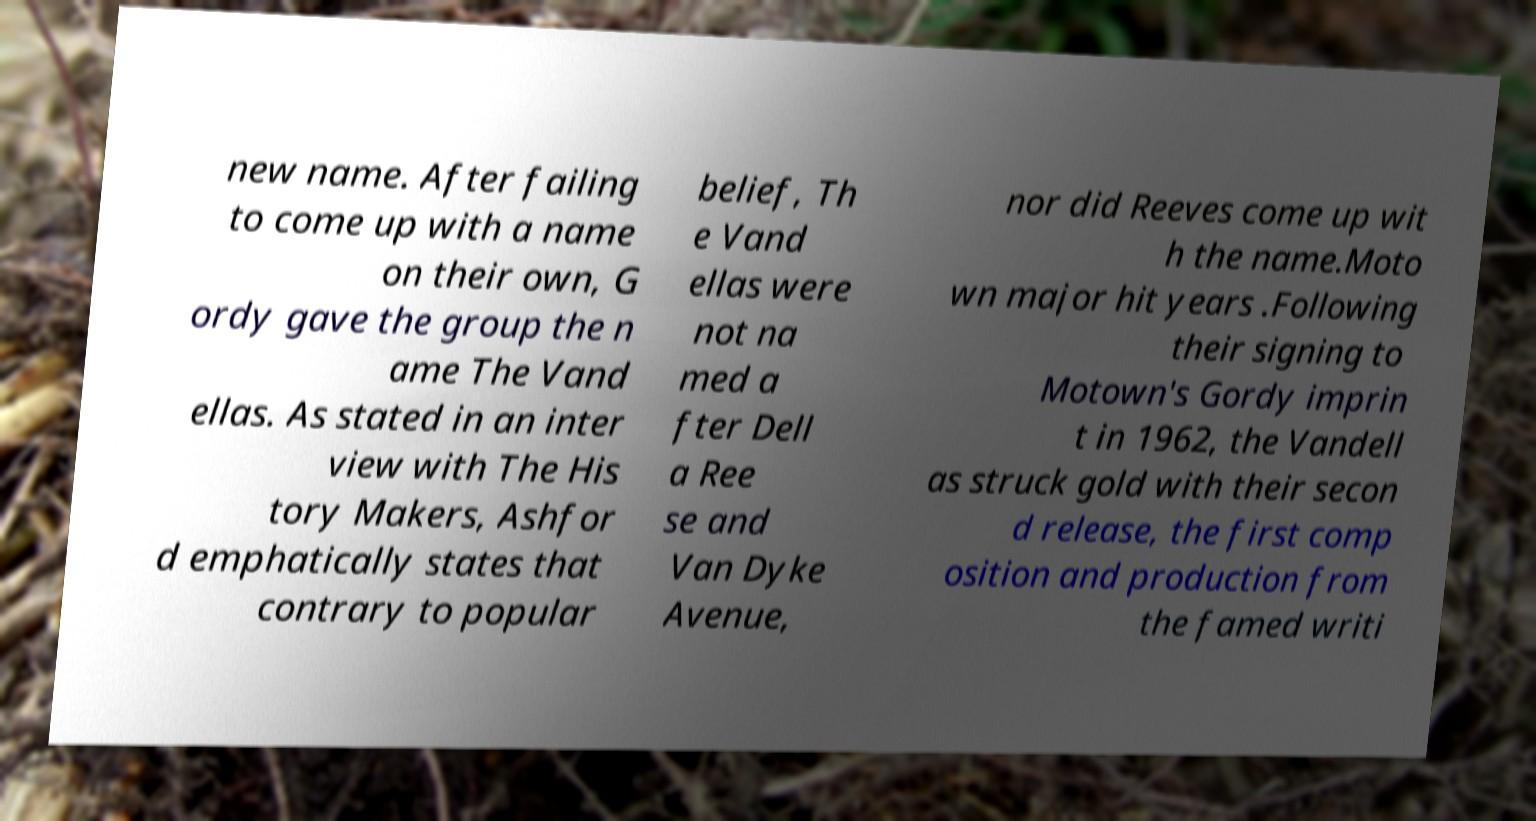Can you read and provide the text displayed in the image?This photo seems to have some interesting text. Can you extract and type it out for me? new name. After failing to come up with a name on their own, G ordy gave the group the n ame The Vand ellas. As stated in an inter view with The His tory Makers, Ashfor d emphatically states that contrary to popular belief, Th e Vand ellas were not na med a fter Dell a Ree se and Van Dyke Avenue, nor did Reeves come up wit h the name.Moto wn major hit years .Following their signing to Motown's Gordy imprin t in 1962, the Vandell as struck gold with their secon d release, the first comp osition and production from the famed writi 